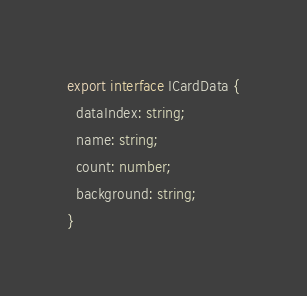<code> <loc_0><loc_0><loc_500><loc_500><_TypeScript_>export interface ICardData {
  dataIndex: string;
  name: string;
  count: number;
  background: string;
}</code> 